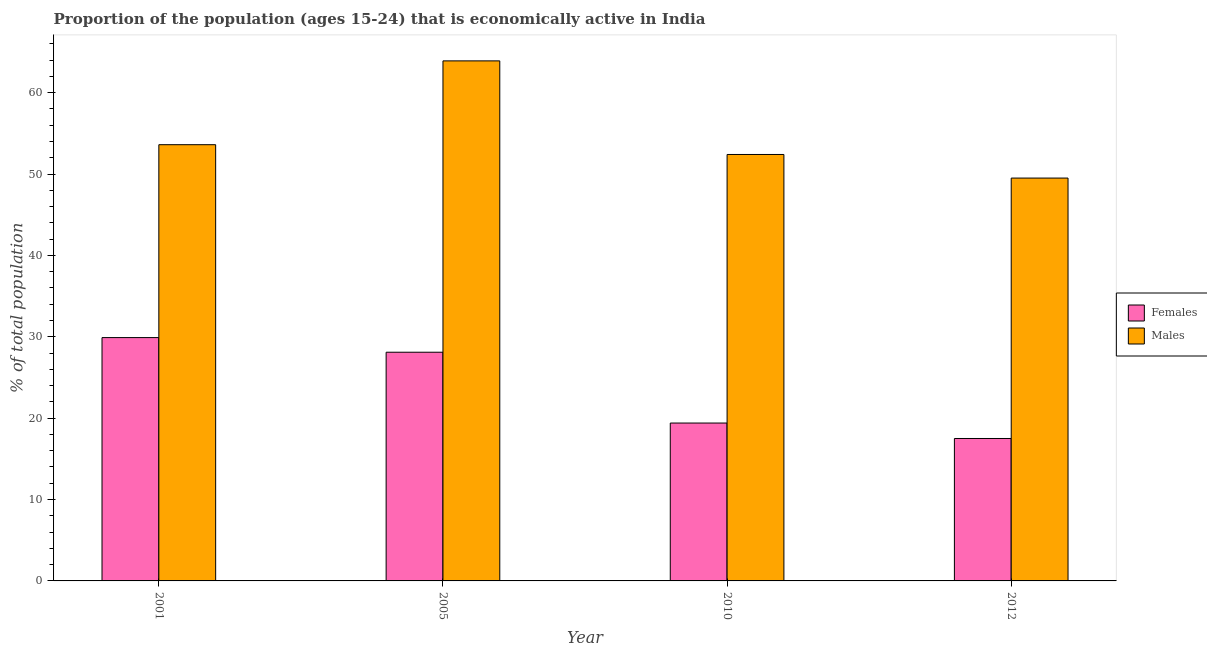How many different coloured bars are there?
Your answer should be very brief. 2. Are the number of bars per tick equal to the number of legend labels?
Your response must be concise. Yes. Are the number of bars on each tick of the X-axis equal?
Ensure brevity in your answer.  Yes. What is the label of the 3rd group of bars from the left?
Keep it short and to the point. 2010. What is the percentage of economically active male population in 2012?
Provide a short and direct response. 49.5. Across all years, what is the maximum percentage of economically active female population?
Make the answer very short. 29.9. Across all years, what is the minimum percentage of economically active male population?
Ensure brevity in your answer.  49.5. What is the total percentage of economically active male population in the graph?
Your answer should be very brief. 219.4. What is the difference between the percentage of economically active female population in 2001 and that in 2005?
Your response must be concise. 1.8. What is the difference between the percentage of economically active female population in 2005 and the percentage of economically active male population in 2001?
Offer a very short reply. -1.8. What is the average percentage of economically active male population per year?
Ensure brevity in your answer.  54.85. In the year 2005, what is the difference between the percentage of economically active female population and percentage of economically active male population?
Make the answer very short. 0. In how many years, is the percentage of economically active male population greater than 22 %?
Your answer should be compact. 4. What is the ratio of the percentage of economically active male population in 2005 to that in 2010?
Provide a short and direct response. 1.22. Is the percentage of economically active male population in 2005 less than that in 2010?
Provide a short and direct response. No. Is the difference between the percentage of economically active female population in 2001 and 2012 greater than the difference between the percentage of economically active male population in 2001 and 2012?
Offer a terse response. No. What is the difference between the highest and the second highest percentage of economically active male population?
Your answer should be very brief. 10.3. What is the difference between the highest and the lowest percentage of economically active female population?
Your response must be concise. 12.4. In how many years, is the percentage of economically active female population greater than the average percentage of economically active female population taken over all years?
Provide a short and direct response. 2. What does the 1st bar from the left in 2005 represents?
Provide a short and direct response. Females. What does the 2nd bar from the right in 2010 represents?
Ensure brevity in your answer.  Females. How many bars are there?
Provide a short and direct response. 8. Are all the bars in the graph horizontal?
Offer a very short reply. No. Are the values on the major ticks of Y-axis written in scientific E-notation?
Your response must be concise. No. Does the graph contain any zero values?
Ensure brevity in your answer.  No. Does the graph contain grids?
Make the answer very short. No. Where does the legend appear in the graph?
Keep it short and to the point. Center right. What is the title of the graph?
Your response must be concise. Proportion of the population (ages 15-24) that is economically active in India. Does "Lowest 20% of population" appear as one of the legend labels in the graph?
Offer a very short reply. No. What is the label or title of the X-axis?
Keep it short and to the point. Year. What is the label or title of the Y-axis?
Ensure brevity in your answer.  % of total population. What is the % of total population of Females in 2001?
Your answer should be compact. 29.9. What is the % of total population in Males in 2001?
Keep it short and to the point. 53.6. What is the % of total population of Females in 2005?
Ensure brevity in your answer.  28.1. What is the % of total population in Males in 2005?
Your response must be concise. 63.9. What is the % of total population of Females in 2010?
Keep it short and to the point. 19.4. What is the % of total population in Males in 2010?
Your answer should be very brief. 52.4. What is the % of total population in Males in 2012?
Provide a short and direct response. 49.5. Across all years, what is the maximum % of total population in Females?
Offer a very short reply. 29.9. Across all years, what is the maximum % of total population in Males?
Ensure brevity in your answer.  63.9. Across all years, what is the minimum % of total population of Females?
Your answer should be compact. 17.5. Across all years, what is the minimum % of total population of Males?
Offer a terse response. 49.5. What is the total % of total population in Females in the graph?
Ensure brevity in your answer.  94.9. What is the total % of total population in Males in the graph?
Give a very brief answer. 219.4. What is the difference between the % of total population of Females in 2001 and that in 2012?
Your answer should be compact. 12.4. What is the difference between the % of total population in Females in 2005 and that in 2010?
Your response must be concise. 8.7. What is the difference between the % of total population in Females in 2005 and that in 2012?
Your answer should be very brief. 10.6. What is the difference between the % of total population of Males in 2005 and that in 2012?
Provide a short and direct response. 14.4. What is the difference between the % of total population in Females in 2001 and the % of total population in Males in 2005?
Your answer should be very brief. -34. What is the difference between the % of total population in Females in 2001 and the % of total population in Males in 2010?
Give a very brief answer. -22.5. What is the difference between the % of total population of Females in 2001 and the % of total population of Males in 2012?
Provide a succinct answer. -19.6. What is the difference between the % of total population in Females in 2005 and the % of total population in Males in 2010?
Offer a terse response. -24.3. What is the difference between the % of total population in Females in 2005 and the % of total population in Males in 2012?
Your answer should be compact. -21.4. What is the difference between the % of total population in Females in 2010 and the % of total population in Males in 2012?
Offer a very short reply. -30.1. What is the average % of total population in Females per year?
Your response must be concise. 23.73. What is the average % of total population in Males per year?
Make the answer very short. 54.85. In the year 2001, what is the difference between the % of total population in Females and % of total population in Males?
Your answer should be very brief. -23.7. In the year 2005, what is the difference between the % of total population in Females and % of total population in Males?
Your answer should be very brief. -35.8. In the year 2010, what is the difference between the % of total population in Females and % of total population in Males?
Your answer should be compact. -33. In the year 2012, what is the difference between the % of total population of Females and % of total population of Males?
Provide a succinct answer. -32. What is the ratio of the % of total population of Females in 2001 to that in 2005?
Offer a very short reply. 1.06. What is the ratio of the % of total population in Males in 2001 to that in 2005?
Offer a very short reply. 0.84. What is the ratio of the % of total population of Females in 2001 to that in 2010?
Your answer should be very brief. 1.54. What is the ratio of the % of total population of Males in 2001 to that in 2010?
Your response must be concise. 1.02. What is the ratio of the % of total population in Females in 2001 to that in 2012?
Keep it short and to the point. 1.71. What is the ratio of the % of total population of Males in 2001 to that in 2012?
Provide a short and direct response. 1.08. What is the ratio of the % of total population in Females in 2005 to that in 2010?
Make the answer very short. 1.45. What is the ratio of the % of total population in Males in 2005 to that in 2010?
Ensure brevity in your answer.  1.22. What is the ratio of the % of total population of Females in 2005 to that in 2012?
Your answer should be compact. 1.61. What is the ratio of the % of total population of Males in 2005 to that in 2012?
Provide a short and direct response. 1.29. What is the ratio of the % of total population of Females in 2010 to that in 2012?
Give a very brief answer. 1.11. What is the ratio of the % of total population in Males in 2010 to that in 2012?
Ensure brevity in your answer.  1.06. What is the difference between the highest and the lowest % of total population of Males?
Ensure brevity in your answer.  14.4. 